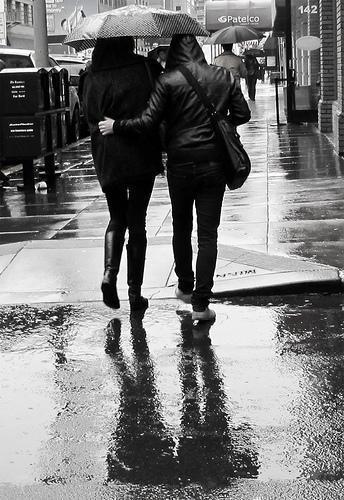What relationship do the persons sharing the umbrella have?
Pick the right solution, then justify: 'Answer: answer
Rationale: rationale.'
Options: Strangers, enemies, intimate, newly met. Answer: intimate.
Rationale: The persons are sharing an umbrella and leaning towards and grasping each other. people who hold each other in this way are likely to be intimate with each other. 